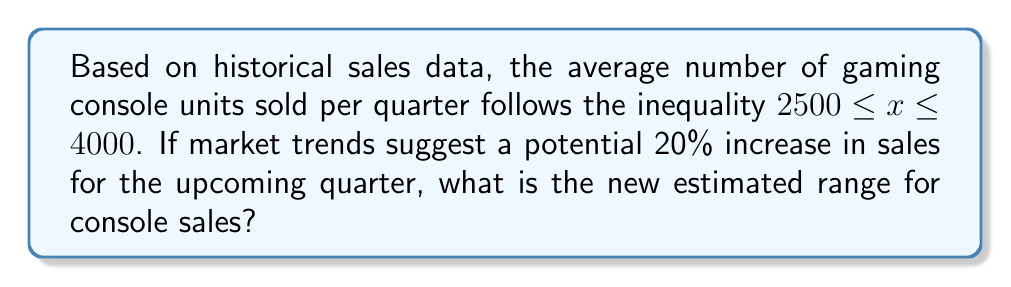Provide a solution to this math problem. Let's approach this step-by-step:

1) The current range is given by the inequality:
   $2500 \leq x \leq 4000$

2) A 20% increase means multiplying the current values by 1.20:
   
   Lower bound: $2500 \times 1.20 = 3000$
   Upper bound: $4000 \times 1.20 = 4800$

3) Therefore, the new range can be expressed as:
   $3000 \leq x \leq 4800$

4) To ensure our answer is as precise as possible, we should round these values to the nearest whole number, as we can't sell fractional consoles.

5) The final inequality representing the new estimated range is:
   $3000 \leq x \leq 4800$
Answer: $3000 \leq x \leq 4800$ 